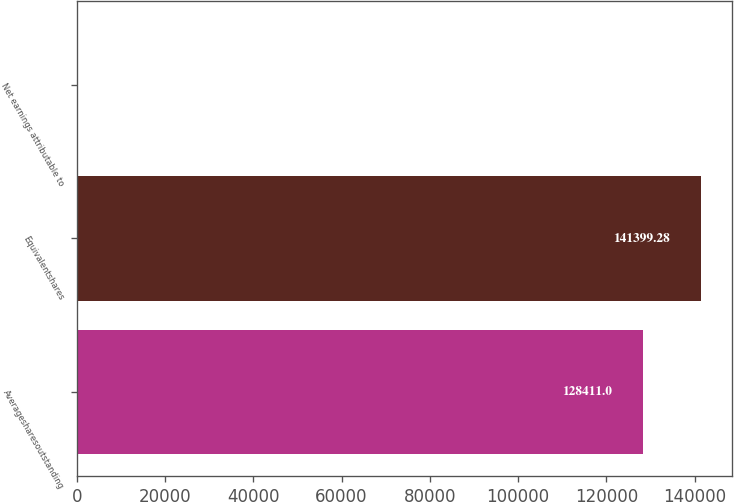<chart> <loc_0><loc_0><loc_500><loc_500><bar_chart><fcel>Averagesharesoutstanding<fcel>Equivalentshares<fcel>Net earnings attributable to<nl><fcel>128411<fcel>141399<fcel>3.2<nl></chart> 